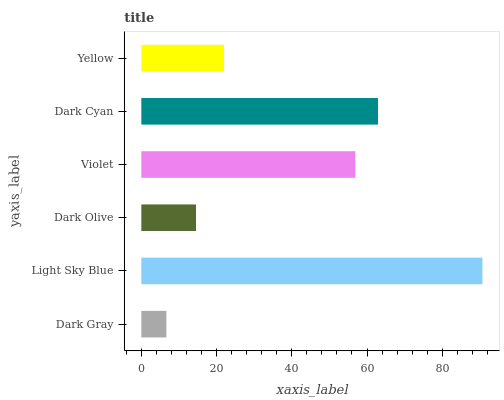Is Dark Gray the minimum?
Answer yes or no. Yes. Is Light Sky Blue the maximum?
Answer yes or no. Yes. Is Dark Olive the minimum?
Answer yes or no. No. Is Dark Olive the maximum?
Answer yes or no. No. Is Light Sky Blue greater than Dark Olive?
Answer yes or no. Yes. Is Dark Olive less than Light Sky Blue?
Answer yes or no. Yes. Is Dark Olive greater than Light Sky Blue?
Answer yes or no. No. Is Light Sky Blue less than Dark Olive?
Answer yes or no. No. Is Violet the high median?
Answer yes or no. Yes. Is Yellow the low median?
Answer yes or no. Yes. Is Light Sky Blue the high median?
Answer yes or no. No. Is Dark Gray the low median?
Answer yes or no. No. 